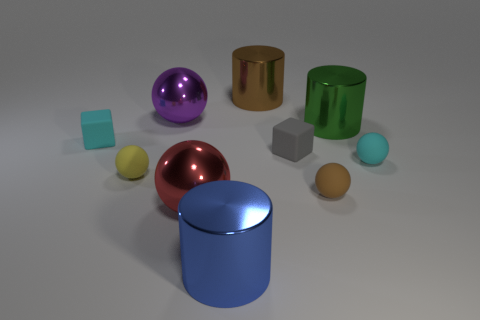Is the size of the block left of the big red metallic thing the same as the metallic ball behind the cyan sphere?
Keep it short and to the point. No. There is a large brown shiny thing; is it the same shape as the big blue metal object that is on the left side of the large green metallic thing?
Keep it short and to the point. Yes. What color is the ball that is behind the small yellow rubber thing and on the right side of the big red ball?
Provide a short and direct response. Cyan. Is there a green cylinder?
Keep it short and to the point. Yes. Are there the same number of small brown things that are on the right side of the gray rubber cube and large brown things?
Keep it short and to the point. Yes. How many other things are there of the same shape as the small brown rubber object?
Your answer should be compact. 4. What is the shape of the purple object?
Give a very brief answer. Sphere. Are the small yellow ball and the big brown thing made of the same material?
Offer a terse response. No. Is the number of objects that are behind the tiny yellow object the same as the number of large objects on the left side of the brown matte thing?
Give a very brief answer. No. There is a big shiny ball that is behind the small gray rubber cube that is left of the large green metal cylinder; is there a large object that is on the right side of it?
Your answer should be compact. Yes. 